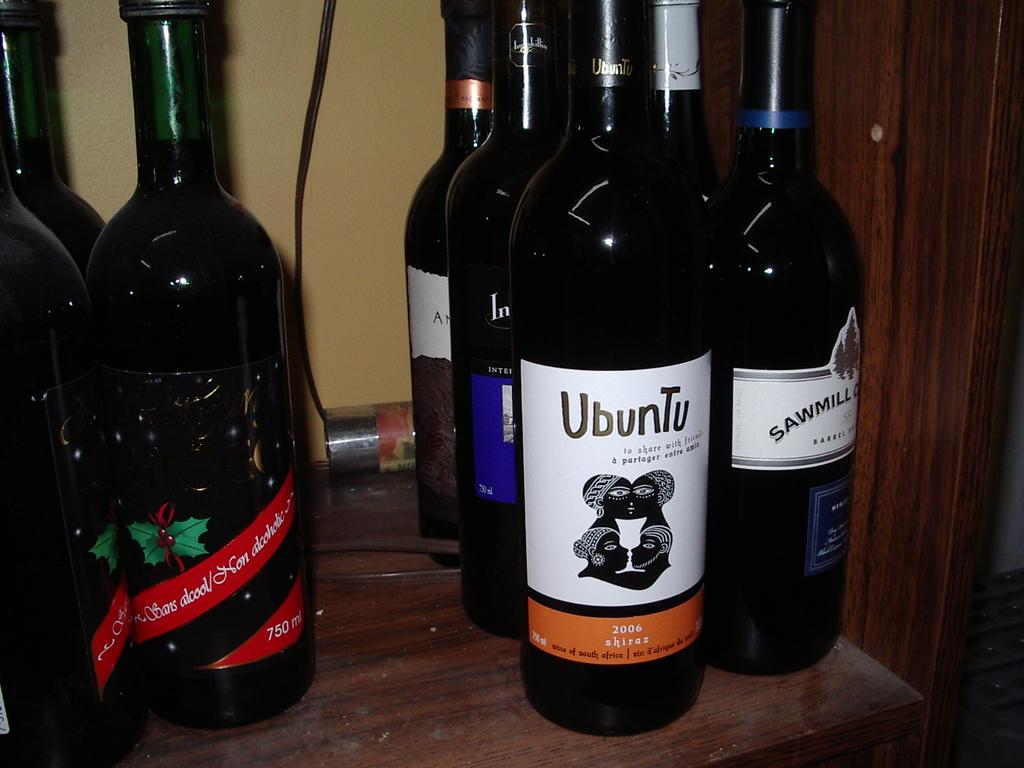<image>
Share a concise interpretation of the image provided. a group of alcohol bottles, one saying Ubuntu and it's from Africa. 